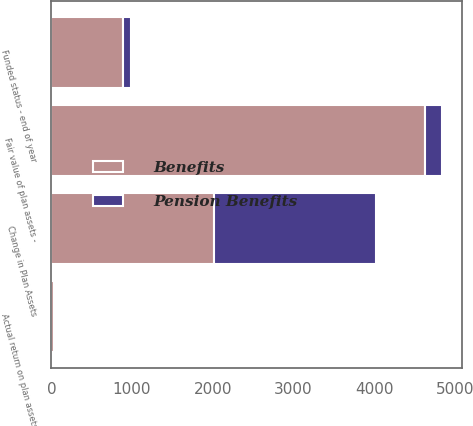<chart> <loc_0><loc_0><loc_500><loc_500><stacked_bar_chart><ecel><fcel>Change in Plan Assets<fcel>Fair value of plan assets -<fcel>Actual return on plan assets<fcel>Funded status - end of year<nl><fcel>Benefits<fcel>2013<fcel>4630<fcel>27<fcel>886<nl><fcel>Pension Benefits<fcel>2013<fcel>213<fcel>13<fcel>99<nl></chart> 